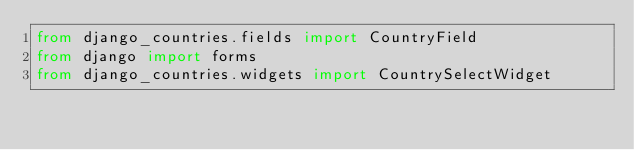Convert code to text. <code><loc_0><loc_0><loc_500><loc_500><_Python_>from django_countries.fields import CountryField
from django import forms
from django_countries.widgets import CountrySelectWidget

</code> 